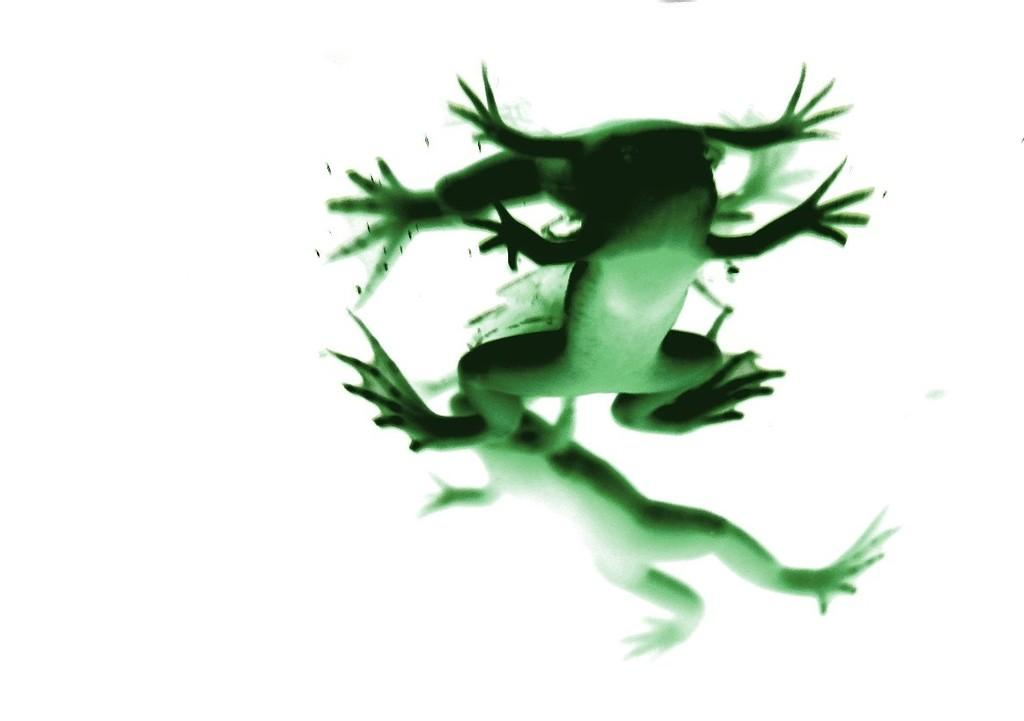What type of animals are in the picture? There are frogs in the picture. What color is the background of the picture? The background of the picture is white. How can we describe the picture? The picture is a depiction, possibly a drawing or illustration. What type of thing is being balanced on the frog's head in the picture? There is no object being balanced on the frog's head in the picture; the image only features frogs. 